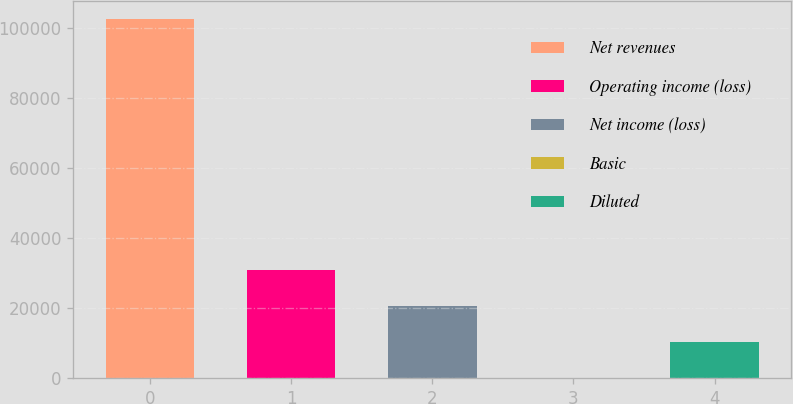Convert chart. <chart><loc_0><loc_0><loc_500><loc_500><bar_chart><fcel>Net revenues<fcel>Operating income (loss)<fcel>Net income (loss)<fcel>Basic<fcel>Diluted<nl><fcel>102606<fcel>30781.8<fcel>20521.2<fcel>0.05<fcel>10260.6<nl></chart> 